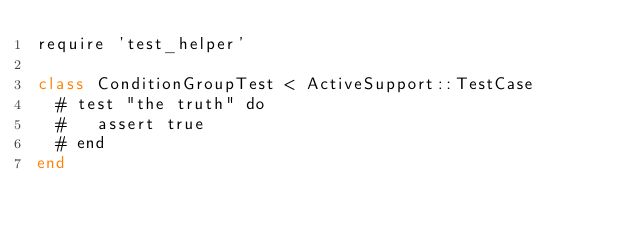Convert code to text. <code><loc_0><loc_0><loc_500><loc_500><_Ruby_>require 'test_helper'

class ConditionGroupTest < ActiveSupport::TestCase
  # test "the truth" do
  #   assert true
  # end
end
</code> 